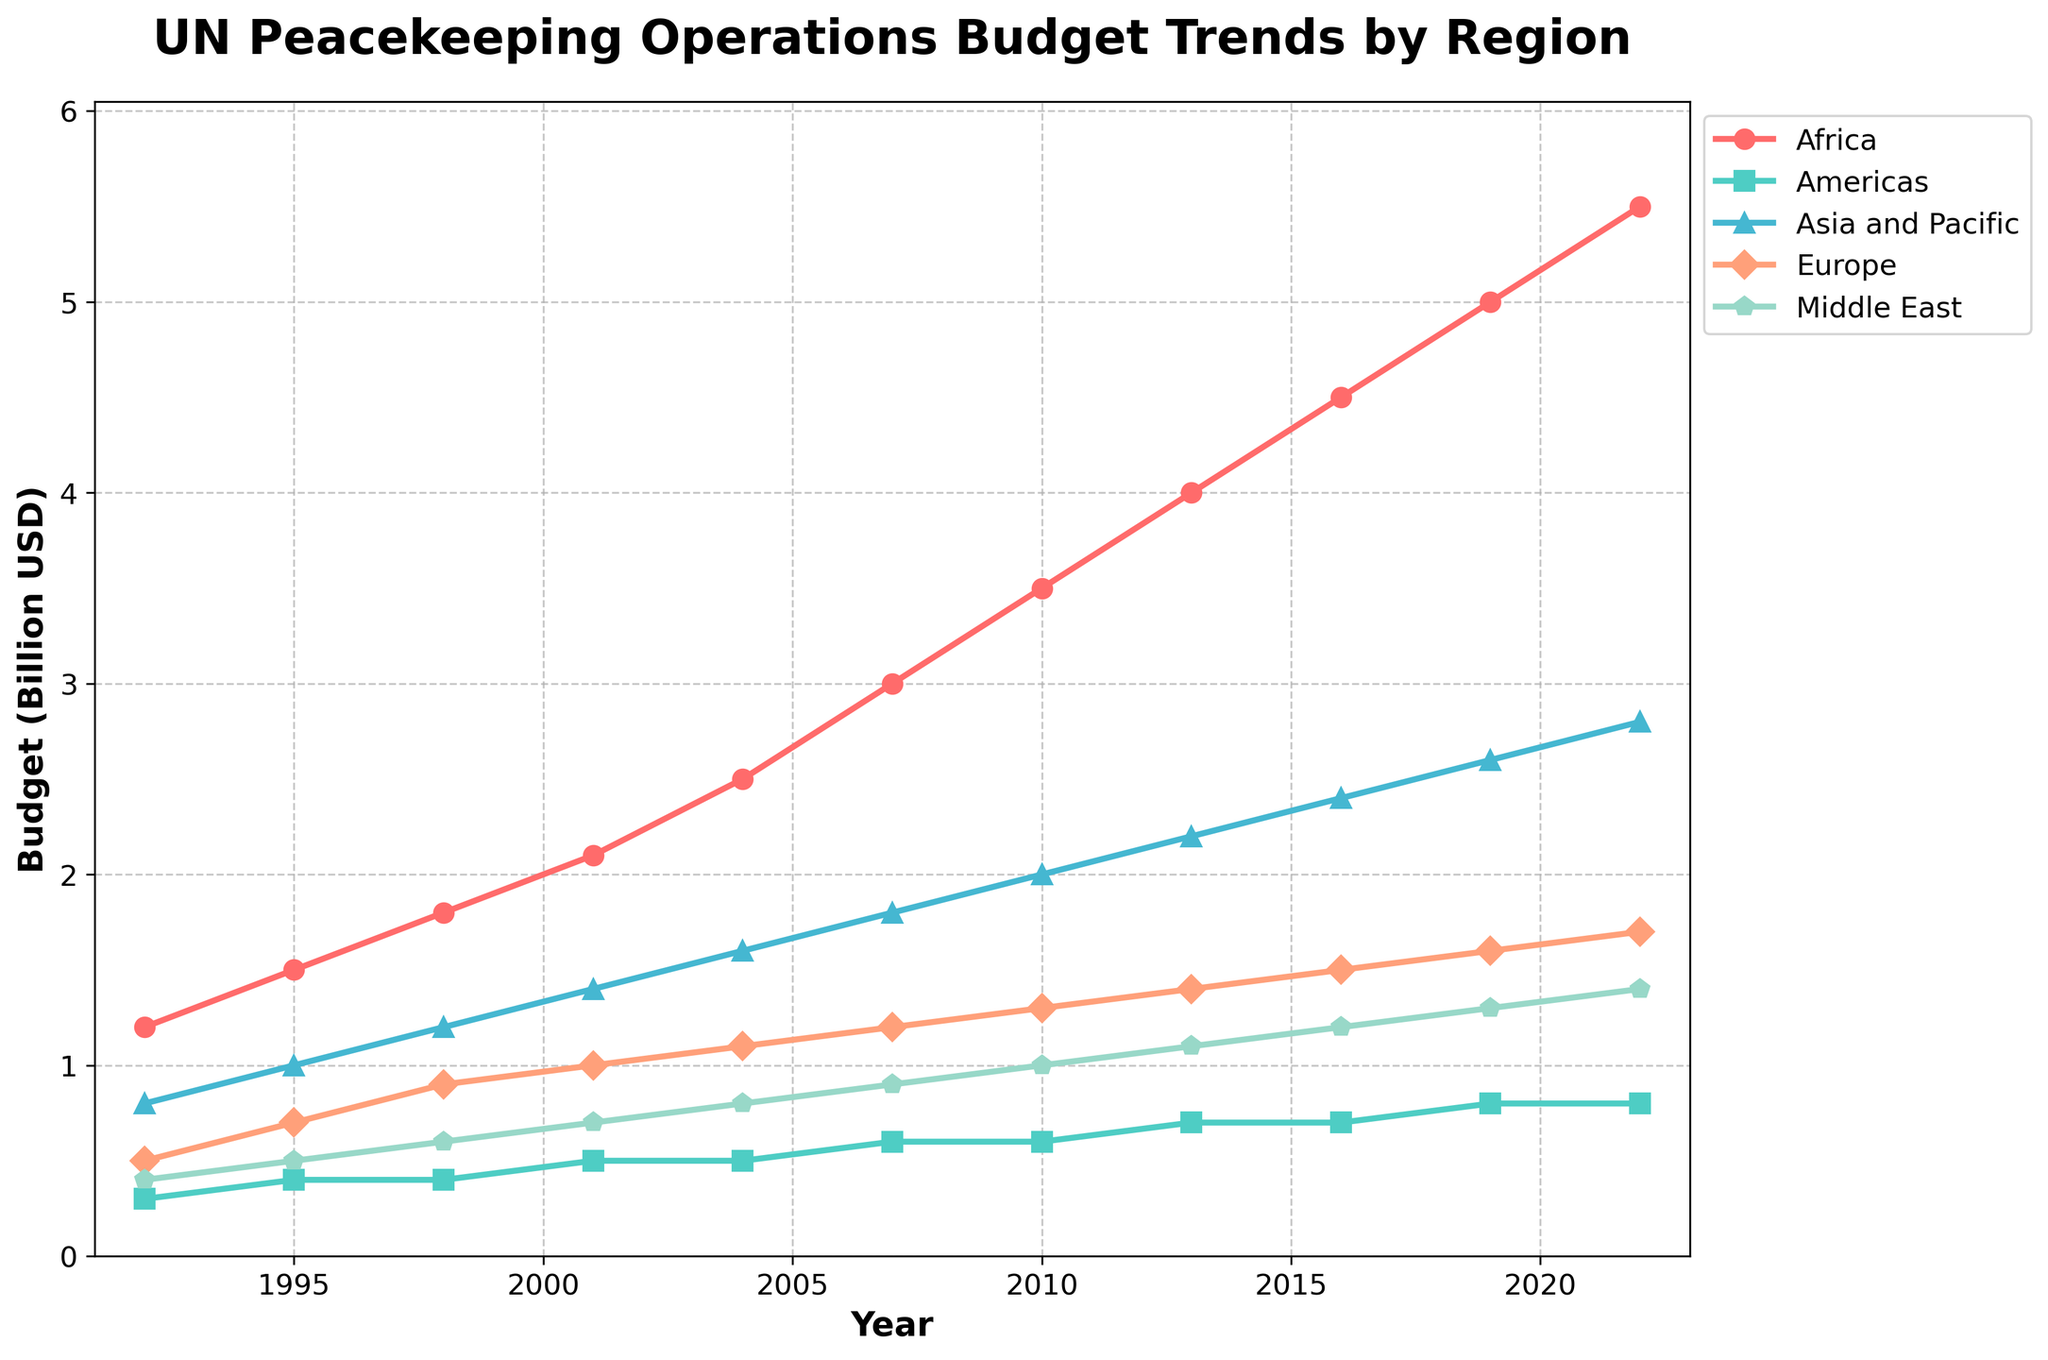What's the trend for the UN peacekeeping budget in Africa over the past 30 years? To determine the trend, look at the line representing Africa on the chart. It starts at 1.2 billion USD in 1992 and rises steadily to 5.5 billion USD in 2022.
Answer: Increasing trend In which year did the Middle East's budget first reach 1 billion USD? Find the line representing the Middle East and see when it crosses the 1 billion USD mark. This happens in 2010.
Answer: 2010 Which region had the smallest budget in 1992? Compare the positions of the lines at the 1992 mark. The Americas line is the lowest at 0.3 billion USD.
Answer: Americas How did the Asia and Pacific budget change from 2016 to 2022? Find the line for Asia and Pacific and compare the values for 2016 (2.4 billion USD) and 2022 (2.8 billion USD). The budget increased by 0.4 billion USD.
Answer: Increased by 0.4 billion USD What's the average budget for Europe over the decades shown? Find the budget values for Europe: 0.5, 0.7, 0.9, 1.0, 1.1, 1.2, 1.3, 1.4, 1.5, 1.6, 1.7. Sum these values (12.9) and divide by the number of values (11).
Answer: 1.17 billion USD Did any region's budget decrease over any interval? Compare the line segments for each region. All lines are consistently increasing from year to year, so no region's budget decreases at any interval.
Answer: No Compare the growth in budget between Africa and the Americas from 1992 to 2022. Africa's budget increased from 1.2 to 5.5 billion USD (an increase of 4.3 billion), while the Americas' budget increased from 0.3 to 0.8 billion USD (an increase of 0.5 billion).
Answer: Africa's budget increased more Which region had the highest budget in 2022? Look at the values for each region in 2022. Africa has the highest budget at 5.5 billion USD.
Answer: Africa Does the Europe budget ever surpass the Asia and Pacific budget in the given period? Compare the lines for Europe and Asia and Pacific throughout the period. Asia and Pacific's line is always above Europe's line, meaning Europe never surpasses it.
Answer: No 